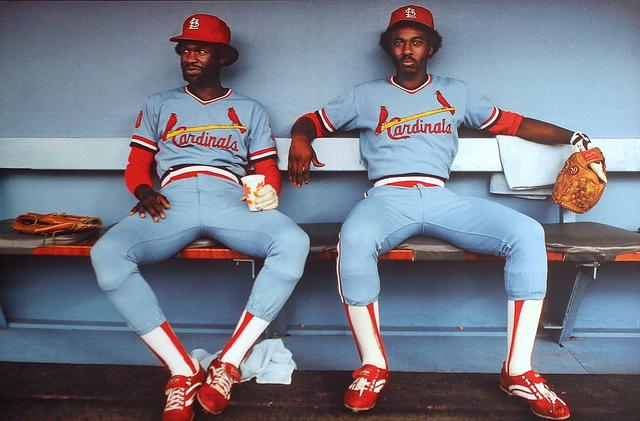Who played for this team? Please explain your reasoning. mark mcgwire. Mark mcgwire played for the cardinals. 